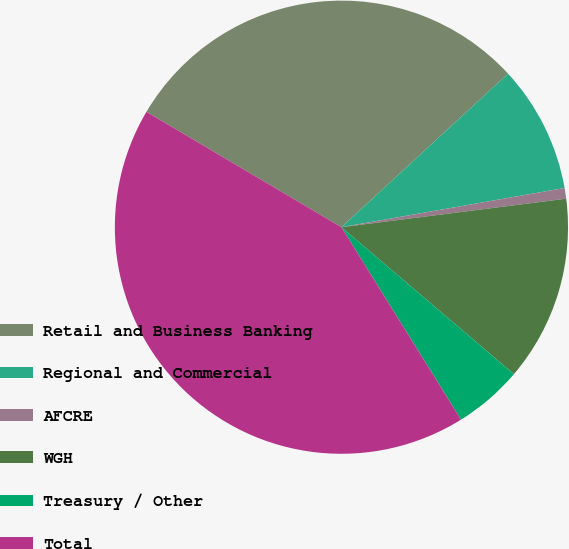Convert chart to OTSL. <chart><loc_0><loc_0><loc_500><loc_500><pie_chart><fcel>Retail and Business Banking<fcel>Regional and Commercial<fcel>AFCRE<fcel>WGH<fcel>Treasury / Other<fcel>Total<nl><fcel>29.65%<fcel>9.08%<fcel>0.76%<fcel>13.24%<fcel>4.92%<fcel>42.35%<nl></chart> 